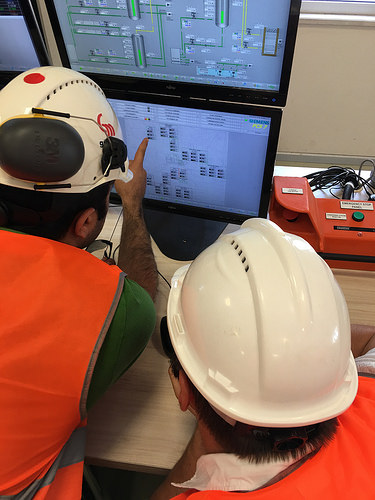<image>
Is the helmet on the man? No. The helmet is not positioned on the man. They may be near each other, but the helmet is not supported by or resting on top of the man. Is the hardhat in front of the computer monitor? Yes. The hardhat is positioned in front of the computer monitor, appearing closer to the camera viewpoint. 